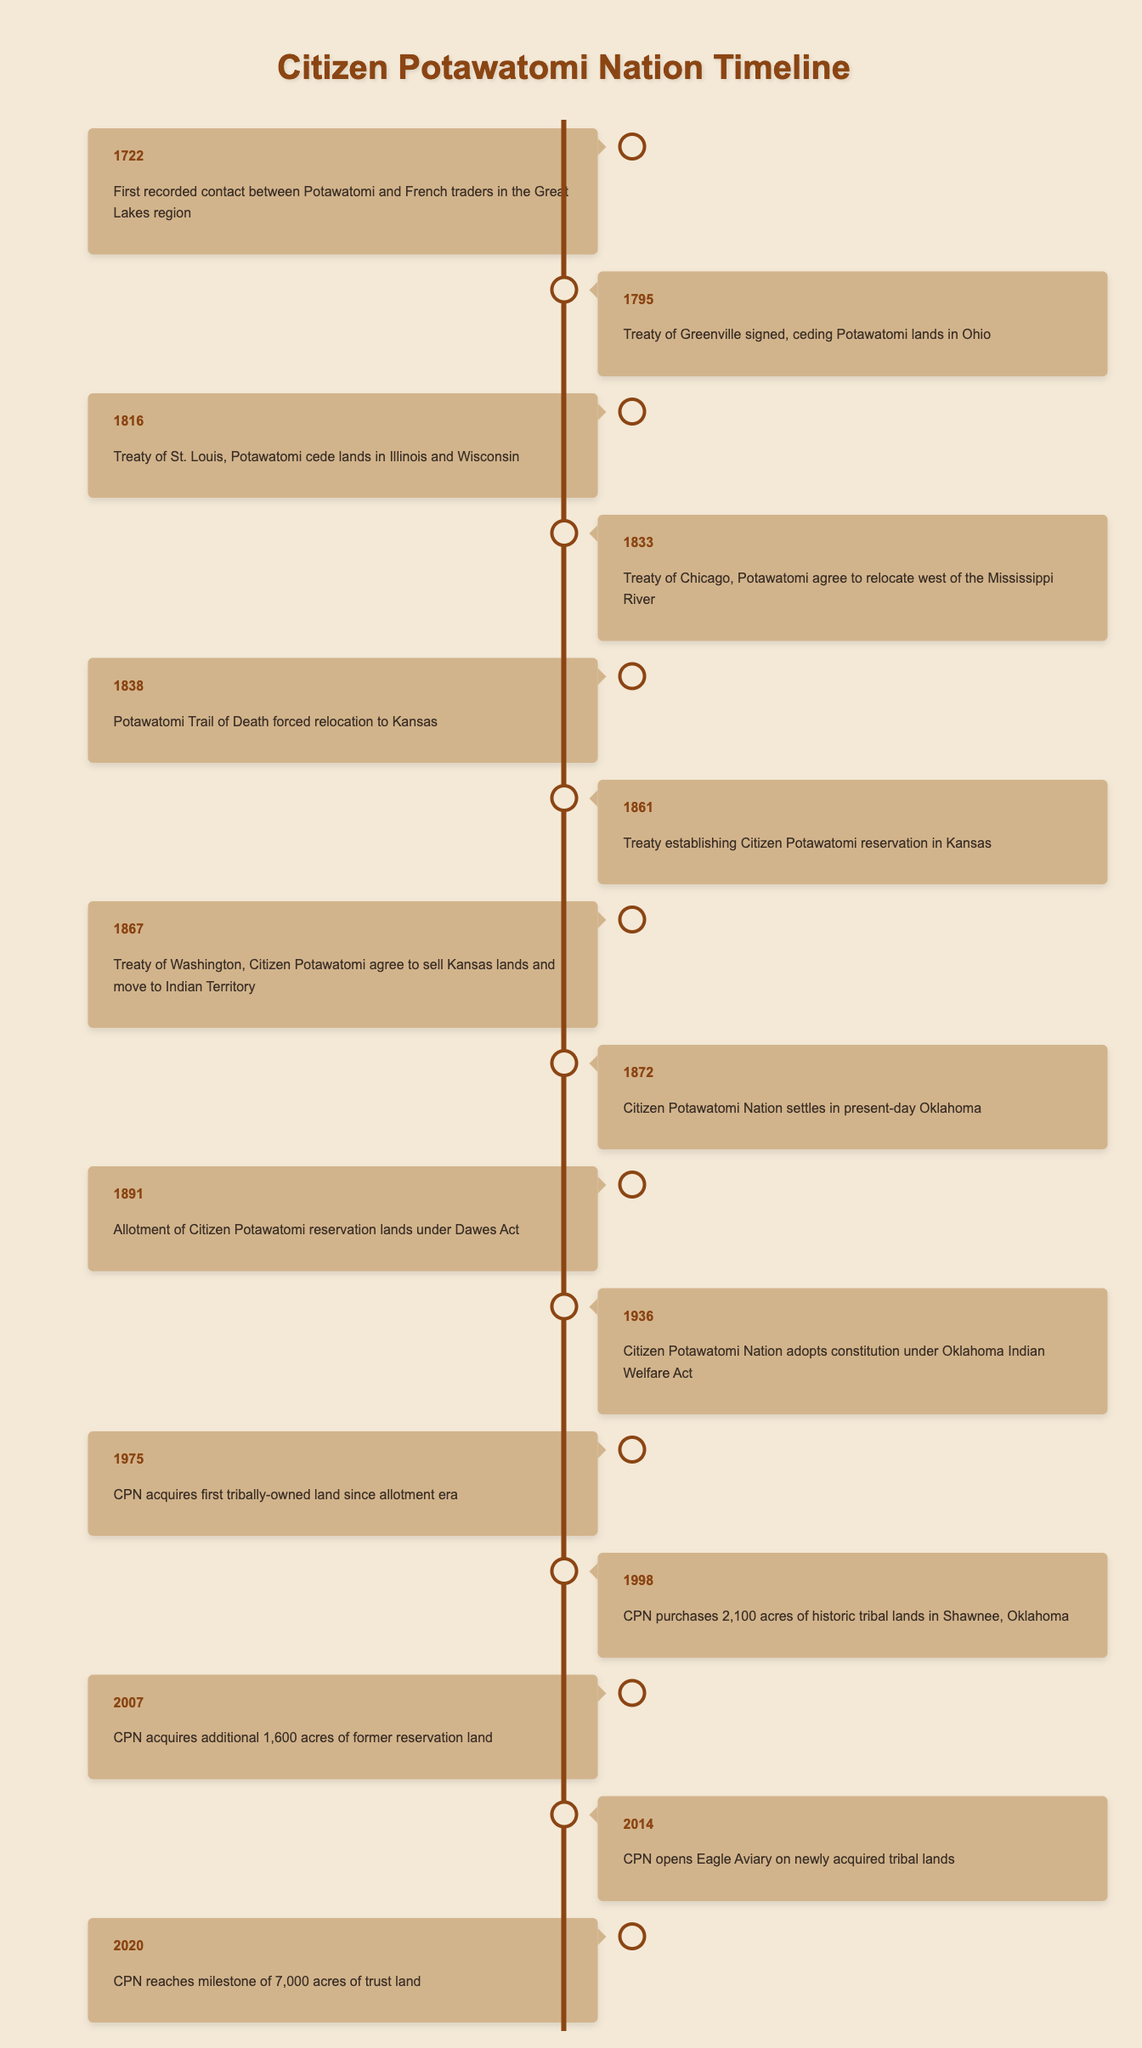What year did the Treaty of Greenville get signed? The table lists an event for the year 1795 which states "Treaty of Greenville signed, ceding Potawatomi lands in Ohio." Therefore, the Treaty of Greenville got signed in 1795.
Answer: 1795 How many acres did CPN purchase in 1998? According to the table, the event for the year 1998 mentions "CPN purchases 2,100 acres of historic tribal lands in Shawnee, Oklahoma." Thus, CPN purchased 2,100 acres in that year.
Answer: 2,100 acres Did the Citizen Potawatomi Nation adopt a constitution before 1940? The timeline shows an event in 1936 stating "Citizen Potawatomi Nation adopts constitution under Oklahoma Indian Welfare Act." This indicates that they did adopt a constitution before 1940.
Answer: Yes In which year did the Potawatomi Trail of Death occur? Referring to the table, the Potawatomi Trail of Death is mentioned under the year 1838. Therefore, it occurred in 1838.
Answer: 1838 What is the total number of acres of trust land CPN reached by 2020? The timeline states that in 2020, CPN reached a milestone of "7,000 acres of trust land". Thus, the total number of acres reached by CPN by 2020 is 7,000 acres.
Answer: 7,000 acres What event happened in 1867 and what was its significance? The table states that in 1867, "Treaty of Washington, Citizen Potawatomi agree to sell Kansas lands and move to Indian Territory." This event was significant as it indicates a continued relocation of the Potawatomi people for the purpose of settling in a designated territory.
Answer: Treaty of Washington, signifies relocation How many years elapsed between the signing of the Treaty of St. Louis and the Treaty of Washington? The Treaty of St. Louis was signed in 1816 and the Treaty of Washington in 1867. The difference in years is 1867 - 1816 = 51 years. Therefore, 51 years elapsed between these treaties.
Answer: 51 years What event took place in 2014 regarding newly acquired tribal lands? According to the table, in 2014, "CPN opens Eagle Aviary on newly acquired tribal lands." This shows that the opening of the Eagle Aviary was associated with those lands.
Answer: Opening of Eagle Aviary Did the CPN acquire any tribally-owned lands after 1975? In the timeline, the first event after 1975 mentioning land acquisition is in 1998 indicating "CPN purchases 2,100 acres of historic tribal lands in Shawnee, Oklahoma." This confirms that they did acquire lands after 1975.
Answer: Yes 